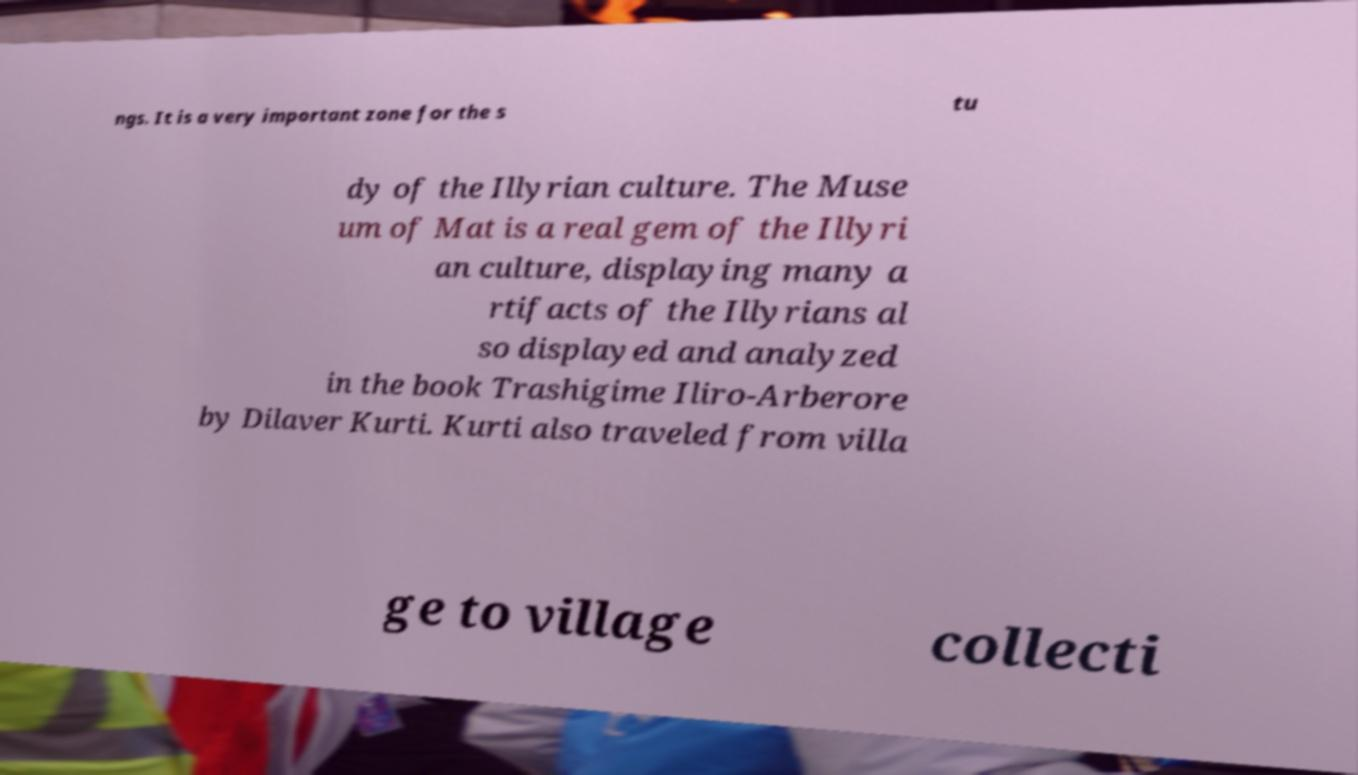Can you accurately transcribe the text from the provided image for me? ngs. It is a very important zone for the s tu dy of the Illyrian culture. The Muse um of Mat is a real gem of the Illyri an culture, displaying many a rtifacts of the Illyrians al so displayed and analyzed in the book Trashigime Iliro-Arberore by Dilaver Kurti. Kurti also traveled from villa ge to village collecti 